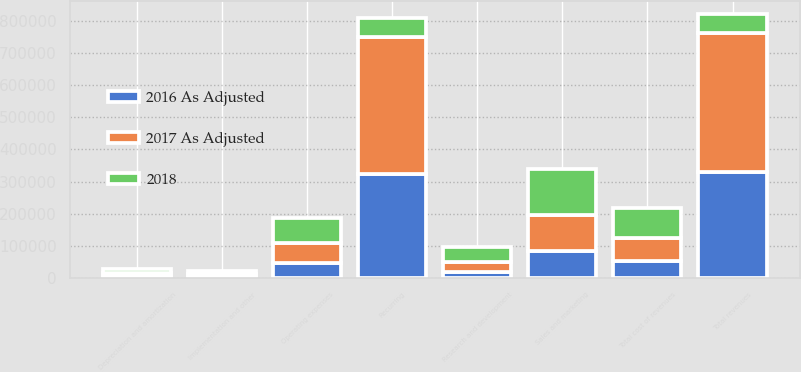Convert chart. <chart><loc_0><loc_0><loc_500><loc_500><stacked_bar_chart><ecel><fcel>Recurring<fcel>Implementation and other<fcel>Total revenues<fcel>Operating expenses<fcel>Depreciation and amortization<fcel>Total cost of revenues<fcel>Sales and marketing<fcel>Research and development<nl><fcel>2018<fcel>58252<fcel>9081<fcel>58252<fcel>76231<fcel>14532<fcel>90763<fcel>143881<fcel>46247<nl><fcel>2017 As Adjusted<fcel>425424<fcel>7623<fcel>433047<fcel>62438<fcel>9590<fcel>72028<fcel>110846<fcel>30430<nl><fcel>2016 As Adjusted<fcel>323548<fcel>5593<fcel>329141<fcel>48268<fcel>5798<fcel>54066<fcel>85361<fcel>20966<nl></chart> 